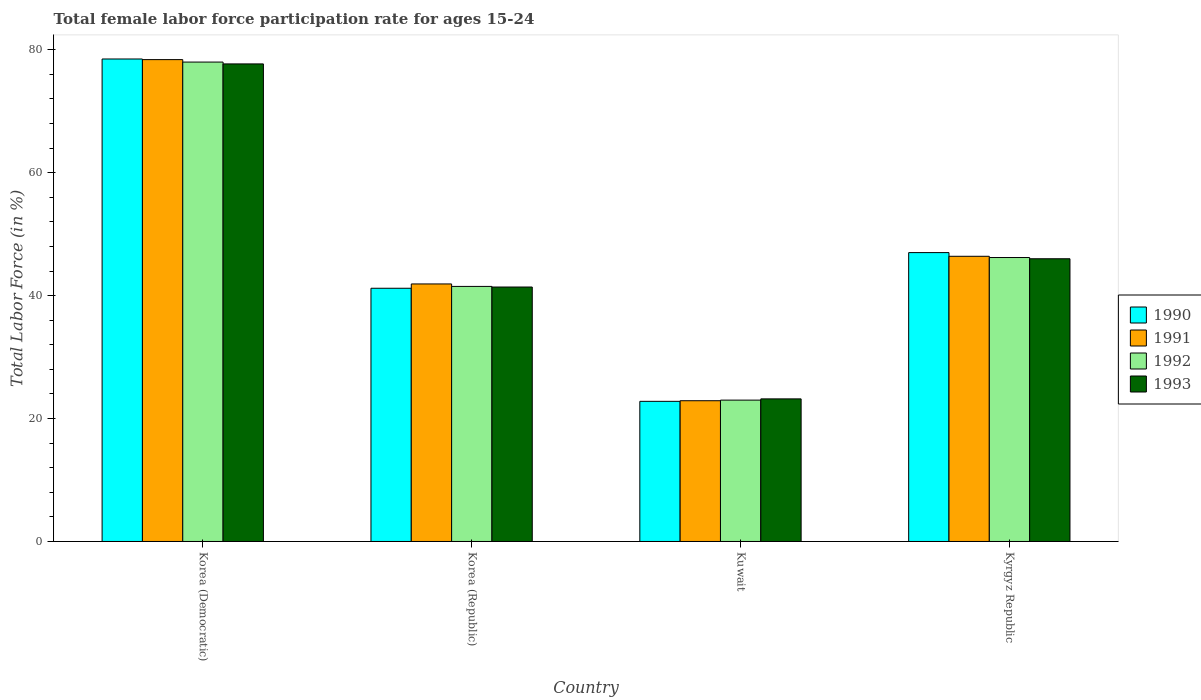Are the number of bars per tick equal to the number of legend labels?
Keep it short and to the point. Yes. How many bars are there on the 3rd tick from the left?
Your response must be concise. 4. What is the label of the 1st group of bars from the left?
Provide a succinct answer. Korea (Democratic). Across all countries, what is the maximum female labor force participation rate in 1991?
Offer a terse response. 78.4. Across all countries, what is the minimum female labor force participation rate in 1990?
Offer a terse response. 22.8. In which country was the female labor force participation rate in 1992 maximum?
Your answer should be compact. Korea (Democratic). In which country was the female labor force participation rate in 1990 minimum?
Provide a succinct answer. Kuwait. What is the total female labor force participation rate in 1993 in the graph?
Offer a terse response. 188.3. What is the difference between the female labor force participation rate in 1993 in Korea (Democratic) and that in Korea (Republic)?
Your response must be concise. 36.3. What is the difference between the female labor force participation rate in 1992 in Kyrgyz Republic and the female labor force participation rate in 1993 in Korea (Republic)?
Your response must be concise. 4.8. What is the average female labor force participation rate in 1993 per country?
Provide a short and direct response. 47.07. What is the difference between the female labor force participation rate of/in 1991 and female labor force participation rate of/in 1992 in Kyrgyz Republic?
Ensure brevity in your answer.  0.2. In how many countries, is the female labor force participation rate in 1993 greater than 8 %?
Provide a short and direct response. 4. What is the ratio of the female labor force participation rate in 1992 in Korea (Republic) to that in Kuwait?
Offer a very short reply. 1.8. What is the difference between the highest and the lowest female labor force participation rate in 1991?
Provide a succinct answer. 55.5. In how many countries, is the female labor force participation rate in 1993 greater than the average female labor force participation rate in 1993 taken over all countries?
Keep it short and to the point. 1. Is it the case that in every country, the sum of the female labor force participation rate in 1993 and female labor force participation rate in 1992 is greater than the sum of female labor force participation rate in 1990 and female labor force participation rate in 1991?
Give a very brief answer. No. What does the 1st bar from the left in Korea (Republic) represents?
Your answer should be compact. 1990. How many bars are there?
Keep it short and to the point. 16. What is the difference between two consecutive major ticks on the Y-axis?
Make the answer very short. 20. Does the graph contain any zero values?
Offer a terse response. No. Where does the legend appear in the graph?
Make the answer very short. Center right. How many legend labels are there?
Ensure brevity in your answer.  4. What is the title of the graph?
Offer a terse response. Total female labor force participation rate for ages 15-24. What is the label or title of the Y-axis?
Your answer should be compact. Total Labor Force (in %). What is the Total Labor Force (in %) in 1990 in Korea (Democratic)?
Your response must be concise. 78.5. What is the Total Labor Force (in %) of 1991 in Korea (Democratic)?
Provide a succinct answer. 78.4. What is the Total Labor Force (in %) of 1993 in Korea (Democratic)?
Offer a terse response. 77.7. What is the Total Labor Force (in %) in 1990 in Korea (Republic)?
Ensure brevity in your answer.  41.2. What is the Total Labor Force (in %) of 1991 in Korea (Republic)?
Make the answer very short. 41.9. What is the Total Labor Force (in %) in 1992 in Korea (Republic)?
Your response must be concise. 41.5. What is the Total Labor Force (in %) in 1993 in Korea (Republic)?
Give a very brief answer. 41.4. What is the Total Labor Force (in %) of 1990 in Kuwait?
Give a very brief answer. 22.8. What is the Total Labor Force (in %) in 1991 in Kuwait?
Your response must be concise. 22.9. What is the Total Labor Force (in %) of 1993 in Kuwait?
Provide a succinct answer. 23.2. What is the Total Labor Force (in %) in 1990 in Kyrgyz Republic?
Provide a succinct answer. 47. What is the Total Labor Force (in %) of 1991 in Kyrgyz Republic?
Give a very brief answer. 46.4. What is the Total Labor Force (in %) of 1992 in Kyrgyz Republic?
Your response must be concise. 46.2. Across all countries, what is the maximum Total Labor Force (in %) in 1990?
Make the answer very short. 78.5. Across all countries, what is the maximum Total Labor Force (in %) of 1991?
Your answer should be very brief. 78.4. Across all countries, what is the maximum Total Labor Force (in %) in 1993?
Your answer should be compact. 77.7. Across all countries, what is the minimum Total Labor Force (in %) in 1990?
Your response must be concise. 22.8. Across all countries, what is the minimum Total Labor Force (in %) of 1991?
Provide a short and direct response. 22.9. Across all countries, what is the minimum Total Labor Force (in %) of 1993?
Provide a succinct answer. 23.2. What is the total Total Labor Force (in %) of 1990 in the graph?
Give a very brief answer. 189.5. What is the total Total Labor Force (in %) of 1991 in the graph?
Make the answer very short. 189.6. What is the total Total Labor Force (in %) of 1992 in the graph?
Give a very brief answer. 188.7. What is the total Total Labor Force (in %) in 1993 in the graph?
Your answer should be very brief. 188.3. What is the difference between the Total Labor Force (in %) in 1990 in Korea (Democratic) and that in Korea (Republic)?
Make the answer very short. 37.3. What is the difference between the Total Labor Force (in %) of 1991 in Korea (Democratic) and that in Korea (Republic)?
Make the answer very short. 36.5. What is the difference between the Total Labor Force (in %) in 1992 in Korea (Democratic) and that in Korea (Republic)?
Provide a short and direct response. 36.5. What is the difference between the Total Labor Force (in %) of 1993 in Korea (Democratic) and that in Korea (Republic)?
Your response must be concise. 36.3. What is the difference between the Total Labor Force (in %) of 1990 in Korea (Democratic) and that in Kuwait?
Your response must be concise. 55.7. What is the difference between the Total Labor Force (in %) in 1991 in Korea (Democratic) and that in Kuwait?
Your response must be concise. 55.5. What is the difference between the Total Labor Force (in %) in 1993 in Korea (Democratic) and that in Kuwait?
Provide a short and direct response. 54.5. What is the difference between the Total Labor Force (in %) of 1990 in Korea (Democratic) and that in Kyrgyz Republic?
Make the answer very short. 31.5. What is the difference between the Total Labor Force (in %) in 1991 in Korea (Democratic) and that in Kyrgyz Republic?
Ensure brevity in your answer.  32. What is the difference between the Total Labor Force (in %) of 1992 in Korea (Democratic) and that in Kyrgyz Republic?
Provide a succinct answer. 31.8. What is the difference between the Total Labor Force (in %) in 1993 in Korea (Democratic) and that in Kyrgyz Republic?
Your answer should be very brief. 31.7. What is the difference between the Total Labor Force (in %) in 1990 in Korea (Republic) and that in Kuwait?
Ensure brevity in your answer.  18.4. What is the difference between the Total Labor Force (in %) in 1993 in Korea (Republic) and that in Kuwait?
Your response must be concise. 18.2. What is the difference between the Total Labor Force (in %) of 1991 in Korea (Republic) and that in Kyrgyz Republic?
Offer a terse response. -4.5. What is the difference between the Total Labor Force (in %) in 1992 in Korea (Republic) and that in Kyrgyz Republic?
Provide a short and direct response. -4.7. What is the difference between the Total Labor Force (in %) of 1990 in Kuwait and that in Kyrgyz Republic?
Provide a succinct answer. -24.2. What is the difference between the Total Labor Force (in %) in 1991 in Kuwait and that in Kyrgyz Republic?
Ensure brevity in your answer.  -23.5. What is the difference between the Total Labor Force (in %) in 1992 in Kuwait and that in Kyrgyz Republic?
Offer a terse response. -23.2. What is the difference between the Total Labor Force (in %) in 1993 in Kuwait and that in Kyrgyz Republic?
Provide a succinct answer. -22.8. What is the difference between the Total Labor Force (in %) of 1990 in Korea (Democratic) and the Total Labor Force (in %) of 1991 in Korea (Republic)?
Offer a terse response. 36.6. What is the difference between the Total Labor Force (in %) in 1990 in Korea (Democratic) and the Total Labor Force (in %) in 1993 in Korea (Republic)?
Keep it short and to the point. 37.1. What is the difference between the Total Labor Force (in %) in 1991 in Korea (Democratic) and the Total Labor Force (in %) in 1992 in Korea (Republic)?
Give a very brief answer. 36.9. What is the difference between the Total Labor Force (in %) of 1992 in Korea (Democratic) and the Total Labor Force (in %) of 1993 in Korea (Republic)?
Provide a short and direct response. 36.6. What is the difference between the Total Labor Force (in %) in 1990 in Korea (Democratic) and the Total Labor Force (in %) in 1991 in Kuwait?
Give a very brief answer. 55.6. What is the difference between the Total Labor Force (in %) in 1990 in Korea (Democratic) and the Total Labor Force (in %) in 1992 in Kuwait?
Give a very brief answer. 55.5. What is the difference between the Total Labor Force (in %) of 1990 in Korea (Democratic) and the Total Labor Force (in %) of 1993 in Kuwait?
Give a very brief answer. 55.3. What is the difference between the Total Labor Force (in %) in 1991 in Korea (Democratic) and the Total Labor Force (in %) in 1992 in Kuwait?
Keep it short and to the point. 55.4. What is the difference between the Total Labor Force (in %) of 1991 in Korea (Democratic) and the Total Labor Force (in %) of 1993 in Kuwait?
Provide a short and direct response. 55.2. What is the difference between the Total Labor Force (in %) in 1992 in Korea (Democratic) and the Total Labor Force (in %) in 1993 in Kuwait?
Provide a short and direct response. 54.8. What is the difference between the Total Labor Force (in %) in 1990 in Korea (Democratic) and the Total Labor Force (in %) in 1991 in Kyrgyz Republic?
Provide a succinct answer. 32.1. What is the difference between the Total Labor Force (in %) in 1990 in Korea (Democratic) and the Total Labor Force (in %) in 1992 in Kyrgyz Republic?
Your answer should be very brief. 32.3. What is the difference between the Total Labor Force (in %) in 1990 in Korea (Democratic) and the Total Labor Force (in %) in 1993 in Kyrgyz Republic?
Make the answer very short. 32.5. What is the difference between the Total Labor Force (in %) of 1991 in Korea (Democratic) and the Total Labor Force (in %) of 1992 in Kyrgyz Republic?
Provide a short and direct response. 32.2. What is the difference between the Total Labor Force (in %) in 1991 in Korea (Democratic) and the Total Labor Force (in %) in 1993 in Kyrgyz Republic?
Give a very brief answer. 32.4. What is the difference between the Total Labor Force (in %) of 1992 in Korea (Democratic) and the Total Labor Force (in %) of 1993 in Kyrgyz Republic?
Offer a terse response. 32. What is the difference between the Total Labor Force (in %) in 1991 in Korea (Republic) and the Total Labor Force (in %) in 1992 in Kuwait?
Give a very brief answer. 18.9. What is the difference between the Total Labor Force (in %) in 1992 in Korea (Republic) and the Total Labor Force (in %) in 1993 in Kuwait?
Ensure brevity in your answer.  18.3. What is the difference between the Total Labor Force (in %) in 1990 in Korea (Republic) and the Total Labor Force (in %) in 1991 in Kyrgyz Republic?
Offer a very short reply. -5.2. What is the difference between the Total Labor Force (in %) of 1990 in Korea (Republic) and the Total Labor Force (in %) of 1993 in Kyrgyz Republic?
Your response must be concise. -4.8. What is the difference between the Total Labor Force (in %) in 1991 in Korea (Republic) and the Total Labor Force (in %) in 1992 in Kyrgyz Republic?
Keep it short and to the point. -4.3. What is the difference between the Total Labor Force (in %) in 1992 in Korea (Republic) and the Total Labor Force (in %) in 1993 in Kyrgyz Republic?
Your response must be concise. -4.5. What is the difference between the Total Labor Force (in %) of 1990 in Kuwait and the Total Labor Force (in %) of 1991 in Kyrgyz Republic?
Ensure brevity in your answer.  -23.6. What is the difference between the Total Labor Force (in %) in 1990 in Kuwait and the Total Labor Force (in %) in 1992 in Kyrgyz Republic?
Your response must be concise. -23.4. What is the difference between the Total Labor Force (in %) in 1990 in Kuwait and the Total Labor Force (in %) in 1993 in Kyrgyz Republic?
Give a very brief answer. -23.2. What is the difference between the Total Labor Force (in %) in 1991 in Kuwait and the Total Labor Force (in %) in 1992 in Kyrgyz Republic?
Give a very brief answer. -23.3. What is the difference between the Total Labor Force (in %) of 1991 in Kuwait and the Total Labor Force (in %) of 1993 in Kyrgyz Republic?
Give a very brief answer. -23.1. What is the difference between the Total Labor Force (in %) in 1992 in Kuwait and the Total Labor Force (in %) in 1993 in Kyrgyz Republic?
Your answer should be compact. -23. What is the average Total Labor Force (in %) in 1990 per country?
Keep it short and to the point. 47.38. What is the average Total Labor Force (in %) of 1991 per country?
Make the answer very short. 47.4. What is the average Total Labor Force (in %) of 1992 per country?
Ensure brevity in your answer.  47.17. What is the average Total Labor Force (in %) of 1993 per country?
Your response must be concise. 47.08. What is the difference between the Total Labor Force (in %) of 1990 and Total Labor Force (in %) of 1991 in Korea (Democratic)?
Provide a short and direct response. 0.1. What is the difference between the Total Labor Force (in %) in 1990 and Total Labor Force (in %) in 1993 in Korea (Democratic)?
Offer a terse response. 0.8. What is the difference between the Total Labor Force (in %) of 1991 and Total Labor Force (in %) of 1992 in Korea (Democratic)?
Your response must be concise. 0.4. What is the difference between the Total Labor Force (in %) in 1992 and Total Labor Force (in %) in 1993 in Korea (Democratic)?
Your answer should be very brief. 0.3. What is the difference between the Total Labor Force (in %) in 1990 and Total Labor Force (in %) in 1991 in Korea (Republic)?
Make the answer very short. -0.7. What is the difference between the Total Labor Force (in %) of 1990 and Total Labor Force (in %) of 1992 in Korea (Republic)?
Provide a short and direct response. -0.3. What is the difference between the Total Labor Force (in %) in 1991 and Total Labor Force (in %) in 1993 in Korea (Republic)?
Offer a very short reply. 0.5. What is the difference between the Total Labor Force (in %) of 1992 and Total Labor Force (in %) of 1993 in Korea (Republic)?
Provide a short and direct response. 0.1. What is the difference between the Total Labor Force (in %) in 1990 and Total Labor Force (in %) in 1992 in Kuwait?
Your response must be concise. -0.2. What is the difference between the Total Labor Force (in %) of 1991 and Total Labor Force (in %) of 1992 in Kuwait?
Give a very brief answer. -0.1. What is the difference between the Total Labor Force (in %) in 1991 and Total Labor Force (in %) in 1993 in Kuwait?
Keep it short and to the point. -0.3. What is the difference between the Total Labor Force (in %) in 1992 and Total Labor Force (in %) in 1993 in Kuwait?
Your answer should be compact. -0.2. What is the difference between the Total Labor Force (in %) of 1990 and Total Labor Force (in %) of 1992 in Kyrgyz Republic?
Your answer should be very brief. 0.8. What is the difference between the Total Labor Force (in %) in 1990 and Total Labor Force (in %) in 1993 in Kyrgyz Republic?
Offer a terse response. 1. What is the difference between the Total Labor Force (in %) in 1991 and Total Labor Force (in %) in 1992 in Kyrgyz Republic?
Your answer should be very brief. 0.2. What is the difference between the Total Labor Force (in %) in 1991 and Total Labor Force (in %) in 1993 in Kyrgyz Republic?
Offer a very short reply. 0.4. What is the ratio of the Total Labor Force (in %) in 1990 in Korea (Democratic) to that in Korea (Republic)?
Provide a succinct answer. 1.91. What is the ratio of the Total Labor Force (in %) of 1991 in Korea (Democratic) to that in Korea (Republic)?
Your answer should be very brief. 1.87. What is the ratio of the Total Labor Force (in %) in 1992 in Korea (Democratic) to that in Korea (Republic)?
Give a very brief answer. 1.88. What is the ratio of the Total Labor Force (in %) in 1993 in Korea (Democratic) to that in Korea (Republic)?
Your response must be concise. 1.88. What is the ratio of the Total Labor Force (in %) in 1990 in Korea (Democratic) to that in Kuwait?
Ensure brevity in your answer.  3.44. What is the ratio of the Total Labor Force (in %) in 1991 in Korea (Democratic) to that in Kuwait?
Provide a succinct answer. 3.42. What is the ratio of the Total Labor Force (in %) of 1992 in Korea (Democratic) to that in Kuwait?
Provide a succinct answer. 3.39. What is the ratio of the Total Labor Force (in %) in 1993 in Korea (Democratic) to that in Kuwait?
Ensure brevity in your answer.  3.35. What is the ratio of the Total Labor Force (in %) in 1990 in Korea (Democratic) to that in Kyrgyz Republic?
Your answer should be compact. 1.67. What is the ratio of the Total Labor Force (in %) in 1991 in Korea (Democratic) to that in Kyrgyz Republic?
Offer a very short reply. 1.69. What is the ratio of the Total Labor Force (in %) in 1992 in Korea (Democratic) to that in Kyrgyz Republic?
Keep it short and to the point. 1.69. What is the ratio of the Total Labor Force (in %) in 1993 in Korea (Democratic) to that in Kyrgyz Republic?
Ensure brevity in your answer.  1.69. What is the ratio of the Total Labor Force (in %) in 1990 in Korea (Republic) to that in Kuwait?
Your response must be concise. 1.81. What is the ratio of the Total Labor Force (in %) of 1991 in Korea (Republic) to that in Kuwait?
Ensure brevity in your answer.  1.83. What is the ratio of the Total Labor Force (in %) in 1992 in Korea (Republic) to that in Kuwait?
Offer a very short reply. 1.8. What is the ratio of the Total Labor Force (in %) in 1993 in Korea (Republic) to that in Kuwait?
Make the answer very short. 1.78. What is the ratio of the Total Labor Force (in %) of 1990 in Korea (Republic) to that in Kyrgyz Republic?
Your answer should be very brief. 0.88. What is the ratio of the Total Labor Force (in %) in 1991 in Korea (Republic) to that in Kyrgyz Republic?
Offer a terse response. 0.9. What is the ratio of the Total Labor Force (in %) of 1992 in Korea (Republic) to that in Kyrgyz Republic?
Provide a short and direct response. 0.9. What is the ratio of the Total Labor Force (in %) in 1990 in Kuwait to that in Kyrgyz Republic?
Offer a terse response. 0.49. What is the ratio of the Total Labor Force (in %) in 1991 in Kuwait to that in Kyrgyz Republic?
Your response must be concise. 0.49. What is the ratio of the Total Labor Force (in %) of 1992 in Kuwait to that in Kyrgyz Republic?
Ensure brevity in your answer.  0.5. What is the ratio of the Total Labor Force (in %) in 1993 in Kuwait to that in Kyrgyz Republic?
Offer a very short reply. 0.5. What is the difference between the highest and the second highest Total Labor Force (in %) of 1990?
Provide a succinct answer. 31.5. What is the difference between the highest and the second highest Total Labor Force (in %) in 1991?
Provide a succinct answer. 32. What is the difference between the highest and the second highest Total Labor Force (in %) in 1992?
Give a very brief answer. 31.8. What is the difference between the highest and the second highest Total Labor Force (in %) in 1993?
Make the answer very short. 31.7. What is the difference between the highest and the lowest Total Labor Force (in %) in 1990?
Your answer should be very brief. 55.7. What is the difference between the highest and the lowest Total Labor Force (in %) in 1991?
Provide a succinct answer. 55.5. What is the difference between the highest and the lowest Total Labor Force (in %) of 1993?
Make the answer very short. 54.5. 